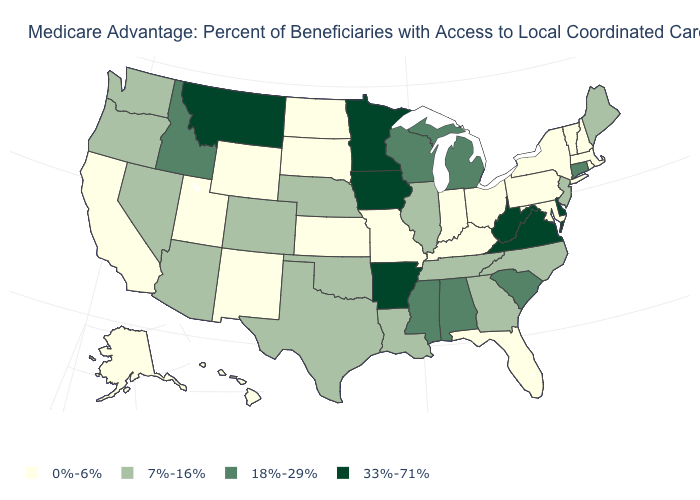What is the value of South Carolina?
Answer briefly. 18%-29%. Is the legend a continuous bar?
Give a very brief answer. No. What is the value of Oregon?
Concise answer only. 7%-16%. Among the states that border Maryland , does Pennsylvania have the lowest value?
Short answer required. Yes. Which states hav the highest value in the West?
Concise answer only. Montana. What is the value of Colorado?
Short answer required. 7%-16%. Which states have the lowest value in the MidWest?
Write a very short answer. Indiana, Kansas, Missouri, North Dakota, Ohio, South Dakota. Which states have the lowest value in the MidWest?
Concise answer only. Indiana, Kansas, Missouri, North Dakota, Ohio, South Dakota. What is the value of North Carolina?
Concise answer only. 7%-16%. Name the states that have a value in the range 0%-6%?
Keep it brief. Alaska, California, Florida, Hawaii, Indiana, Kansas, Kentucky, Massachusetts, Maryland, Missouri, North Dakota, New Hampshire, New Mexico, New York, Ohio, Pennsylvania, Rhode Island, South Dakota, Utah, Vermont, Wyoming. Name the states that have a value in the range 7%-16%?
Write a very short answer. Arizona, Colorado, Georgia, Illinois, Louisiana, Maine, North Carolina, Nebraska, New Jersey, Nevada, Oklahoma, Oregon, Tennessee, Texas, Washington. What is the value of Georgia?
Be succinct. 7%-16%. Name the states that have a value in the range 18%-29%?
Concise answer only. Alabama, Connecticut, Idaho, Michigan, Mississippi, South Carolina, Wisconsin. Does Missouri have the lowest value in the USA?
Keep it brief. Yes. 